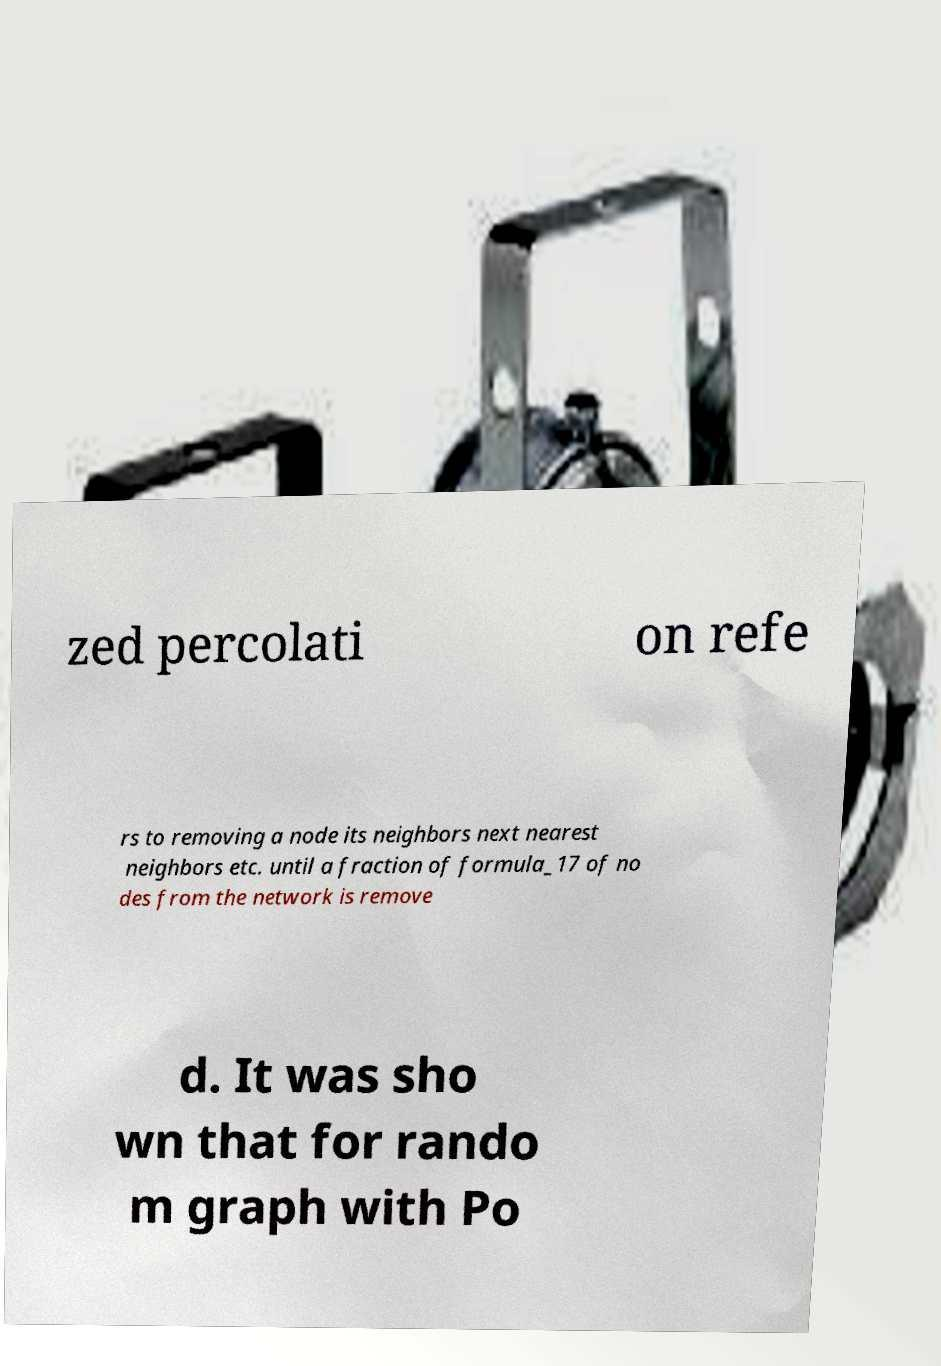Please read and relay the text visible in this image. What does it say? zed percolati on refe rs to removing a node its neighbors next nearest neighbors etc. until a fraction of formula_17 of no des from the network is remove d. It was sho wn that for rando m graph with Po 